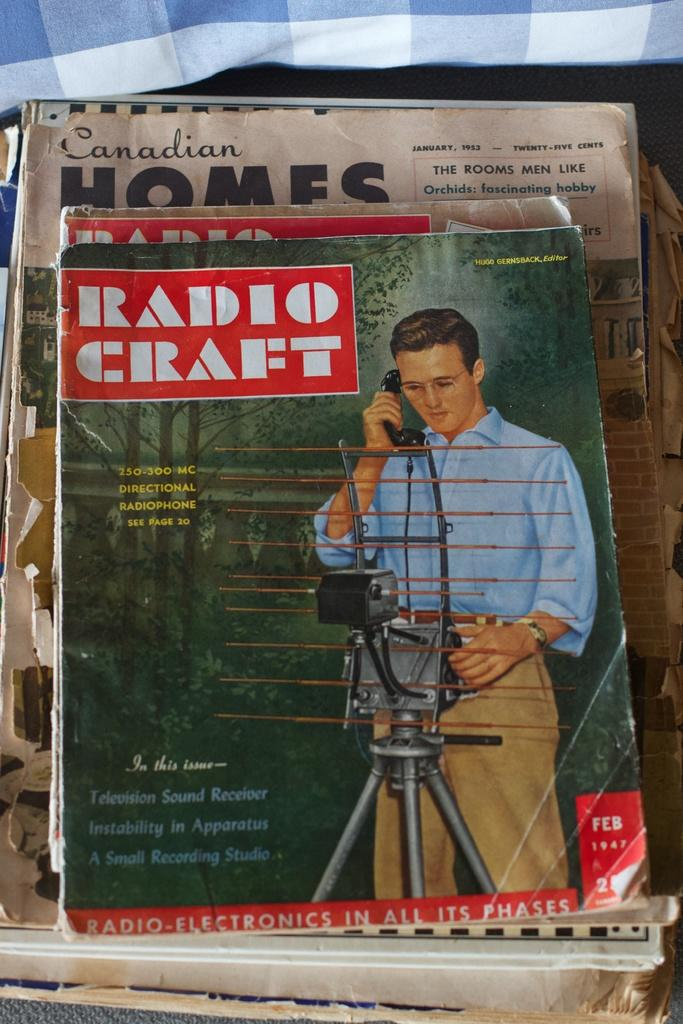<image>
Present a compact description of the photo's key features. A magazine called Radio Craft has a 250-300 MC directional radio phone on page 20. 